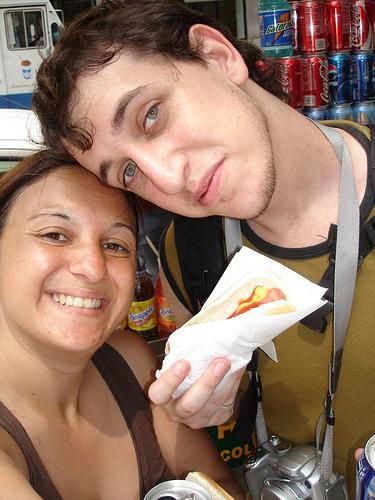Question: what is she holding?
Choices:
A. Soda pop.
B. Candy.
C. Hot dog.
D. Popcorn.
Answer with the letter. Answer: C Question: why is she smiling?
Choices:
A. She's happy.
B. She's flirting.
C. Taking a picture.
D. She is meeting her boyfriend.
Answer with the letter. Answer: C Question: who is smiling?
Choices:
A. The child.
B. The man.
C. The girl.
D. The woman.
Answer with the letter. Answer: C Question: where is the guy?
Choices:
A. In the car.
B. In the street.
C. Next to the girl.
D. In the park.
Answer with the letter. Answer: C Question: what is he touching?
Choices:
A. Her head.
B. Her hair.
C. Her cheek.
D. Her neck.
Answer with the letter. Answer: A Question: how many hot dogs?
Choices:
A. 1.
B. 2.
C. 3.
D. 4.
Answer with the letter. Answer: A Question: what is on the guys neck?
Choices:
A. Wound.
B. Scarf.
C. Camera.
D. Collar.
Answer with the letter. Answer: C 